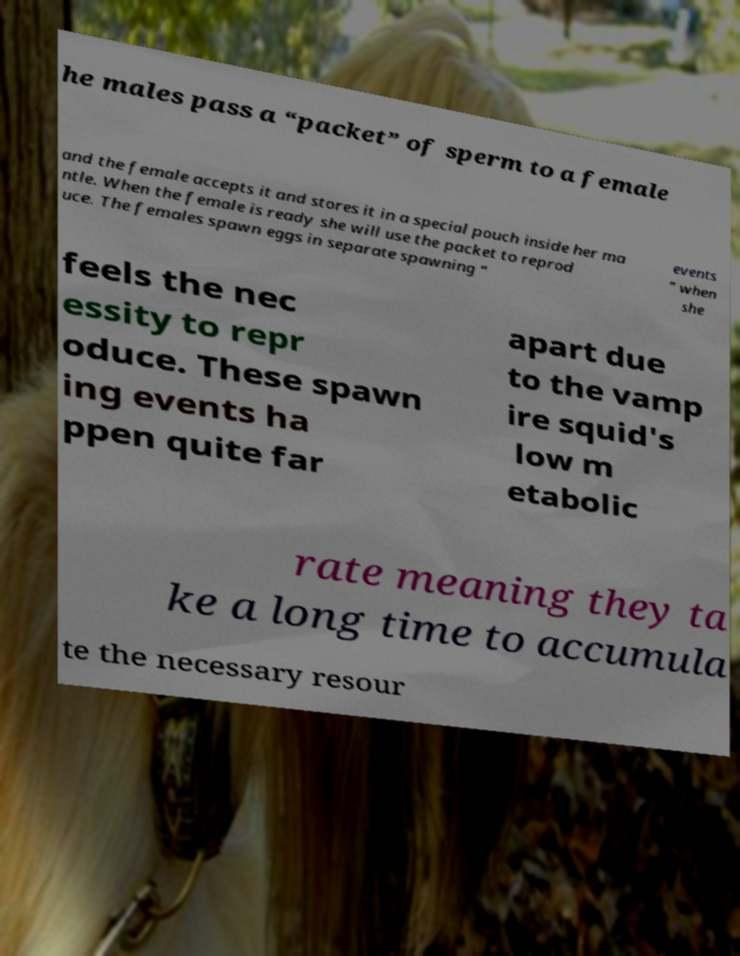For documentation purposes, I need the text within this image transcribed. Could you provide that? he males pass a “packet” of sperm to a female and the female accepts it and stores it in a special pouch inside her ma ntle. When the female is ready she will use the packet to reprod uce. The females spawn eggs in separate spawning “ events ” when she feels the nec essity to repr oduce. These spawn ing events ha ppen quite far apart due to the vamp ire squid's low m etabolic rate meaning they ta ke a long time to accumula te the necessary resour 